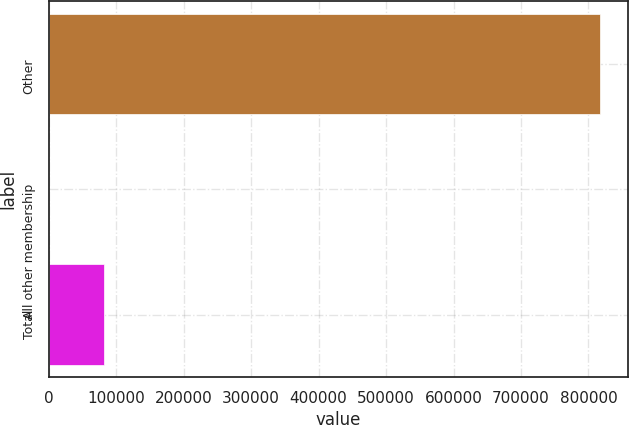Convert chart. <chart><loc_0><loc_0><loc_500><loc_500><bar_chart><fcel>Other<fcel>All other membership<fcel>Total<nl><fcel>817800<fcel>75.7<fcel>81848.1<nl></chart> 